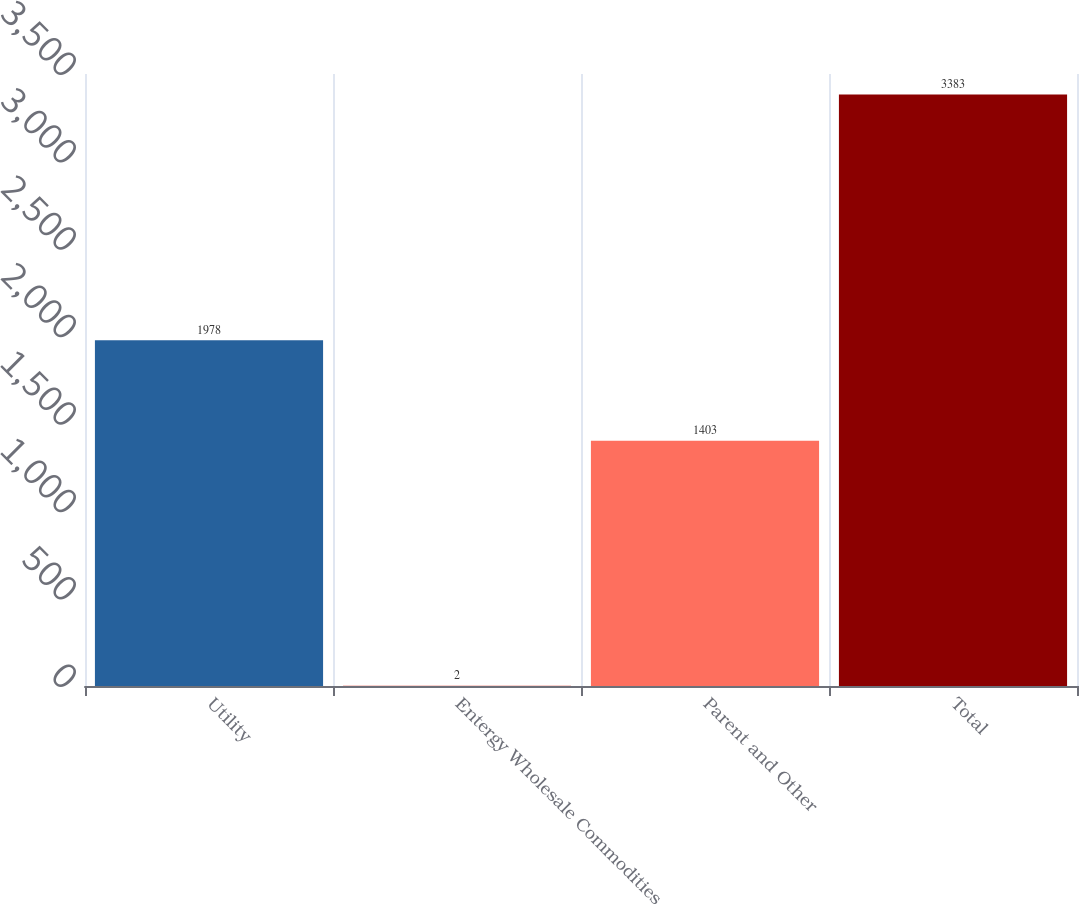<chart> <loc_0><loc_0><loc_500><loc_500><bar_chart><fcel>Utility<fcel>Entergy Wholesale Commodities<fcel>Parent and Other<fcel>Total<nl><fcel>1978<fcel>2<fcel>1403<fcel>3383<nl></chart> 